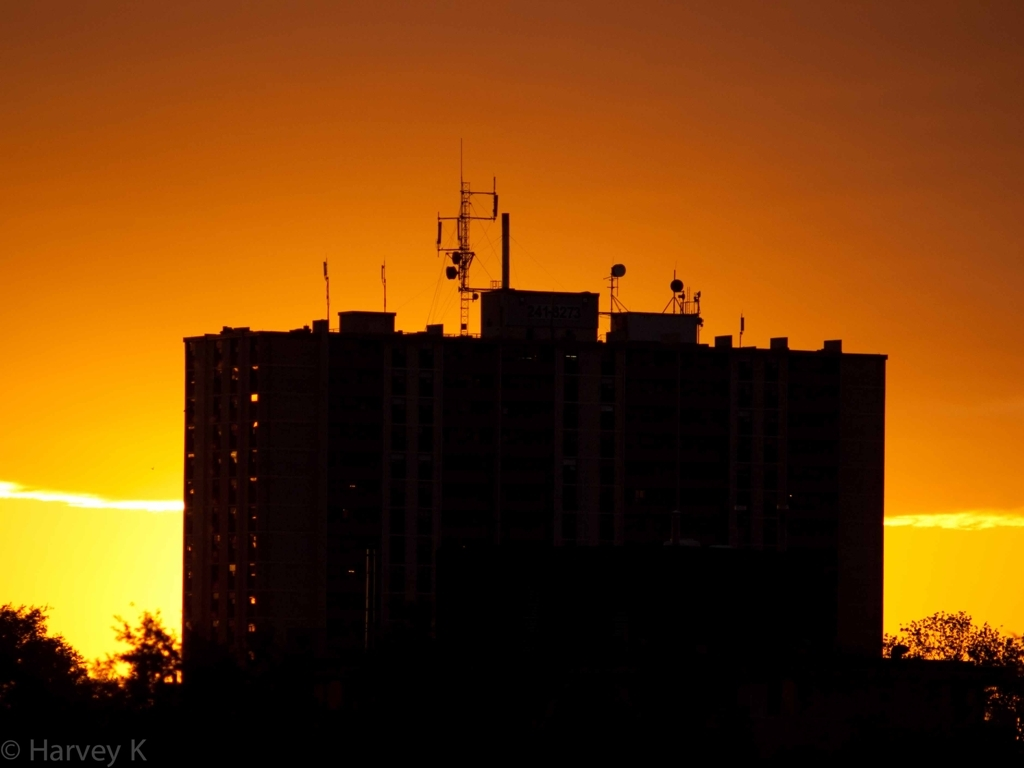What time of day does this image depict? The image captures the beauty of a sunset, characterized by the warm golden hues in the sky and the silhouette of the building against the diminishing daylight. 